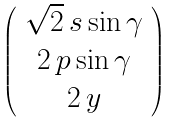<formula> <loc_0><loc_0><loc_500><loc_500>\left ( \begin{array} { c } \sqrt { 2 } \, s \sin \gamma \\ 2 \, p \sin \gamma \\ 2 \, y \end{array} \right )</formula> 